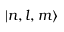Convert formula to latex. <formula><loc_0><loc_0><loc_500><loc_500>| n , l , m \rangle</formula> 